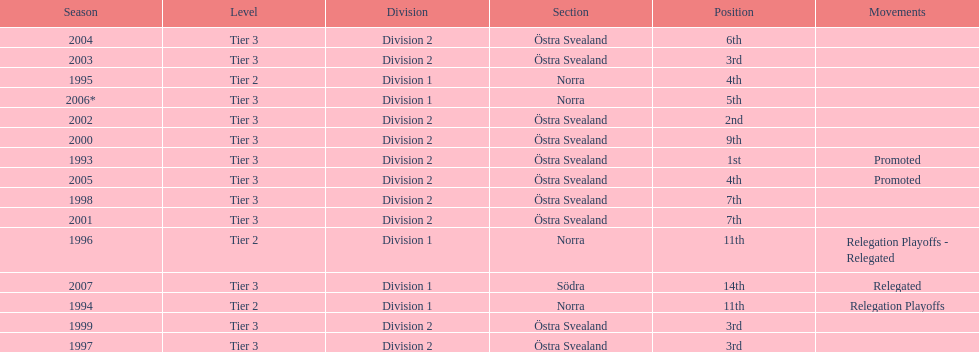What year is at least on the list? 2007. 